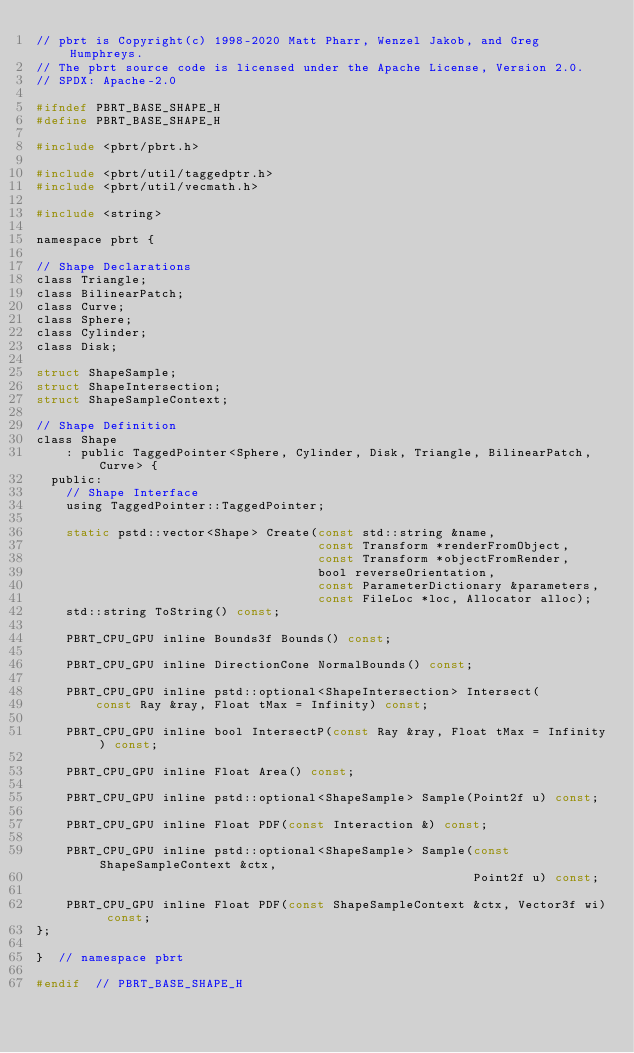<code> <loc_0><loc_0><loc_500><loc_500><_C_>// pbrt is Copyright(c) 1998-2020 Matt Pharr, Wenzel Jakob, and Greg Humphreys.
// The pbrt source code is licensed under the Apache License, Version 2.0.
// SPDX: Apache-2.0

#ifndef PBRT_BASE_SHAPE_H
#define PBRT_BASE_SHAPE_H

#include <pbrt/pbrt.h>

#include <pbrt/util/taggedptr.h>
#include <pbrt/util/vecmath.h>

#include <string>

namespace pbrt {

// Shape Declarations
class Triangle;
class BilinearPatch;
class Curve;
class Sphere;
class Cylinder;
class Disk;

struct ShapeSample;
struct ShapeIntersection;
struct ShapeSampleContext;

// Shape Definition
class Shape
    : public TaggedPointer<Sphere, Cylinder, Disk, Triangle, BilinearPatch, Curve> {
  public:
    // Shape Interface
    using TaggedPointer::TaggedPointer;

    static pstd::vector<Shape> Create(const std::string &name,
                                      const Transform *renderFromObject,
                                      const Transform *objectFromRender,
                                      bool reverseOrientation,
                                      const ParameterDictionary &parameters,
                                      const FileLoc *loc, Allocator alloc);
    std::string ToString() const;

    PBRT_CPU_GPU inline Bounds3f Bounds() const;

    PBRT_CPU_GPU inline DirectionCone NormalBounds() const;

    PBRT_CPU_GPU inline pstd::optional<ShapeIntersection> Intersect(
        const Ray &ray, Float tMax = Infinity) const;

    PBRT_CPU_GPU inline bool IntersectP(const Ray &ray, Float tMax = Infinity) const;

    PBRT_CPU_GPU inline Float Area() const;

    PBRT_CPU_GPU inline pstd::optional<ShapeSample> Sample(Point2f u) const;

    PBRT_CPU_GPU inline Float PDF(const Interaction &) const;

    PBRT_CPU_GPU inline pstd::optional<ShapeSample> Sample(const ShapeSampleContext &ctx,
                                                           Point2f u) const;

    PBRT_CPU_GPU inline Float PDF(const ShapeSampleContext &ctx, Vector3f wi) const;
};

}  // namespace pbrt

#endif  // PBRT_BASE_SHAPE_H
</code> 